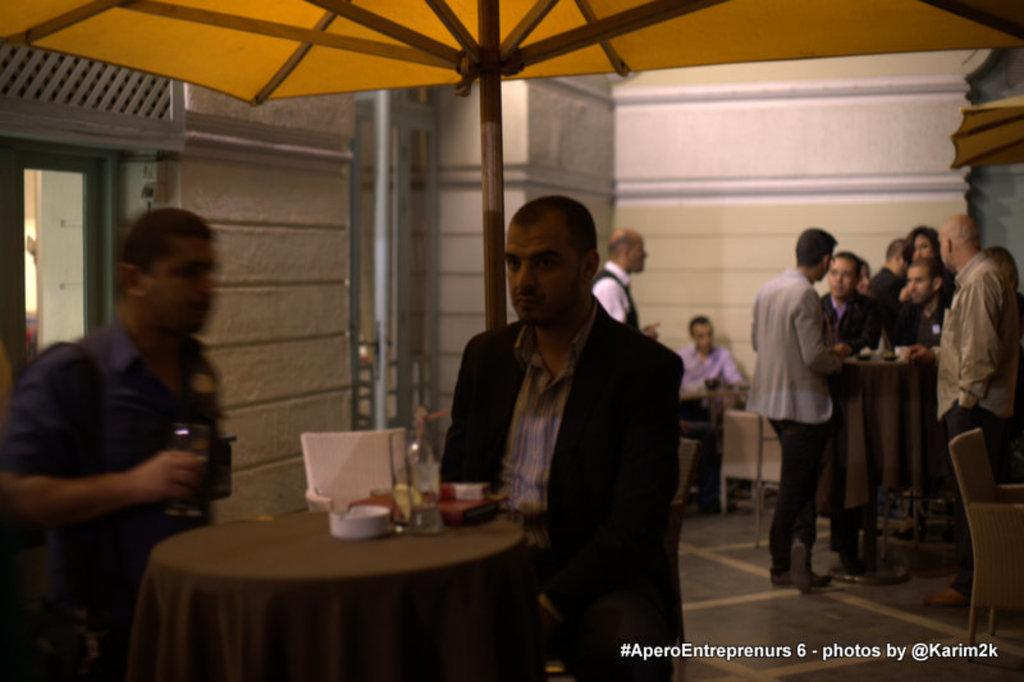How many people are in the room in the image? There are many people in the room in the image. What type of furniture is present in the room? There are tables and chairs in the room. What can be found on the tables in the room? There are bowls and other items on the tables. Is there any specific object mentioned in the image? Yes, there is an umbrella in the room. What can be seen in the background of the image? There is a wall in the background. What type of reward is being given to the people in the image? There is no mention of a reward being given to the people in the image. Can you see any air or flames in the image? No, there is no air or flames present in the image. 